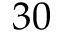Convert formula to latex. <formula><loc_0><loc_0><loc_500><loc_500>3 0</formula> 